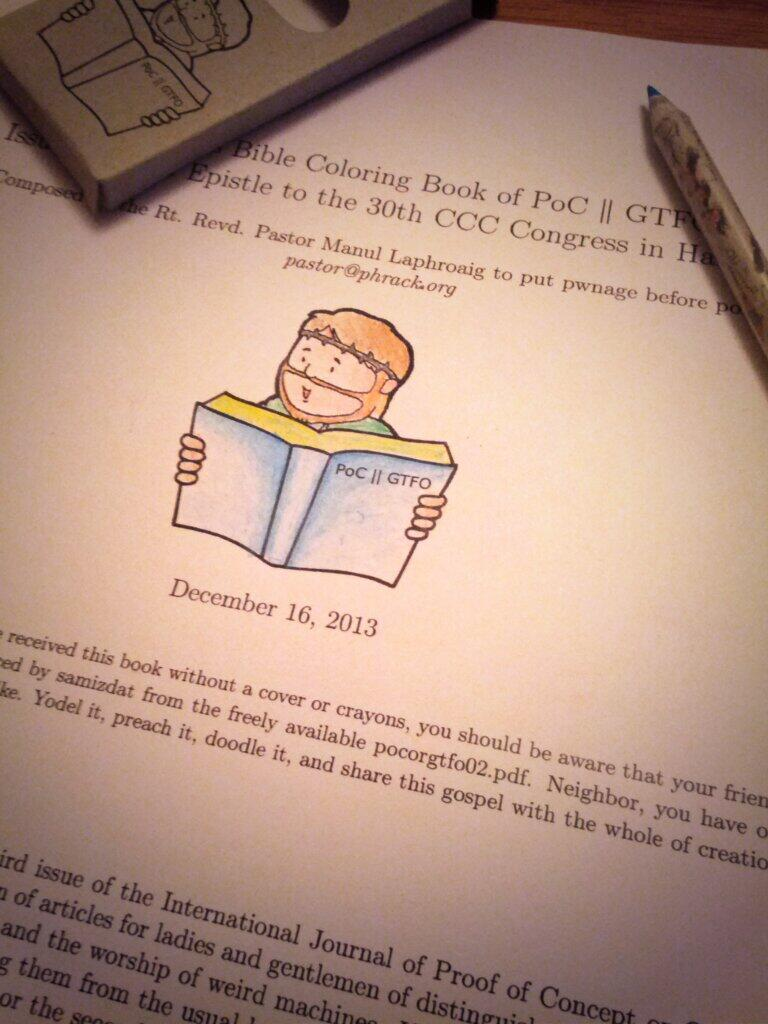Provide a one-sentence caption for the provided image. A pen sits on a table next to a page from a Bible themed coloring book. 